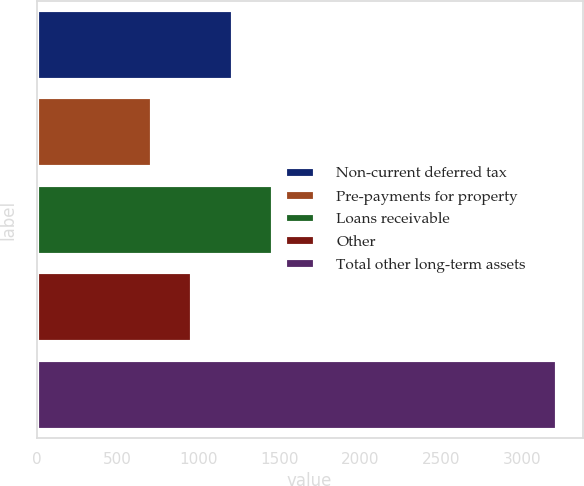Convert chart. <chart><loc_0><loc_0><loc_500><loc_500><bar_chart><fcel>Non-current deferred tax<fcel>Pre-payments for property<fcel>Loans receivable<fcel>Other<fcel>Total other long-term assets<nl><fcel>1214.2<fcel>714<fcel>1464.3<fcel>964.1<fcel>3215<nl></chart> 